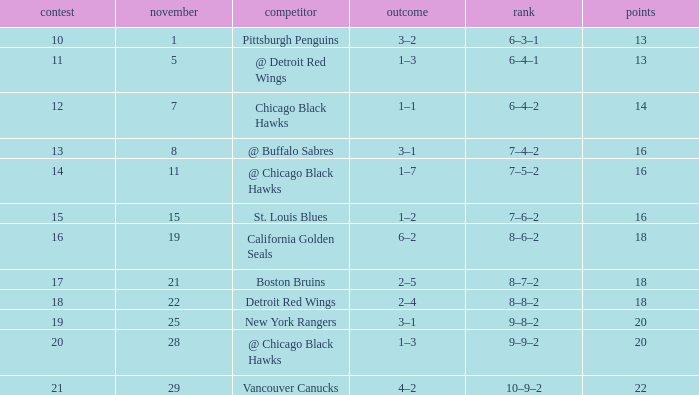Which opponent has points less than 18, and a november greater than 11? St. Louis Blues. 